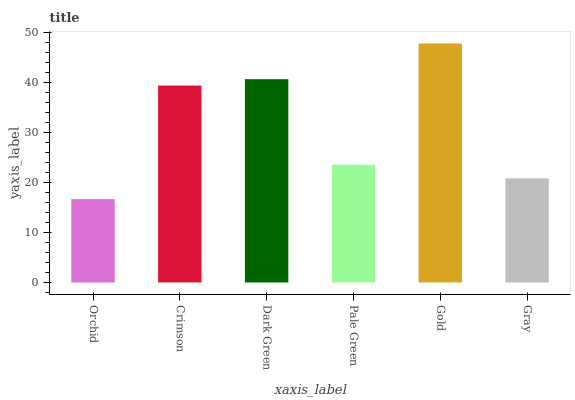Is Crimson the minimum?
Answer yes or no. No. Is Crimson the maximum?
Answer yes or no. No. Is Crimson greater than Orchid?
Answer yes or no. Yes. Is Orchid less than Crimson?
Answer yes or no. Yes. Is Orchid greater than Crimson?
Answer yes or no. No. Is Crimson less than Orchid?
Answer yes or no. No. Is Crimson the high median?
Answer yes or no. Yes. Is Pale Green the low median?
Answer yes or no. Yes. Is Gold the high median?
Answer yes or no. No. Is Orchid the low median?
Answer yes or no. No. 